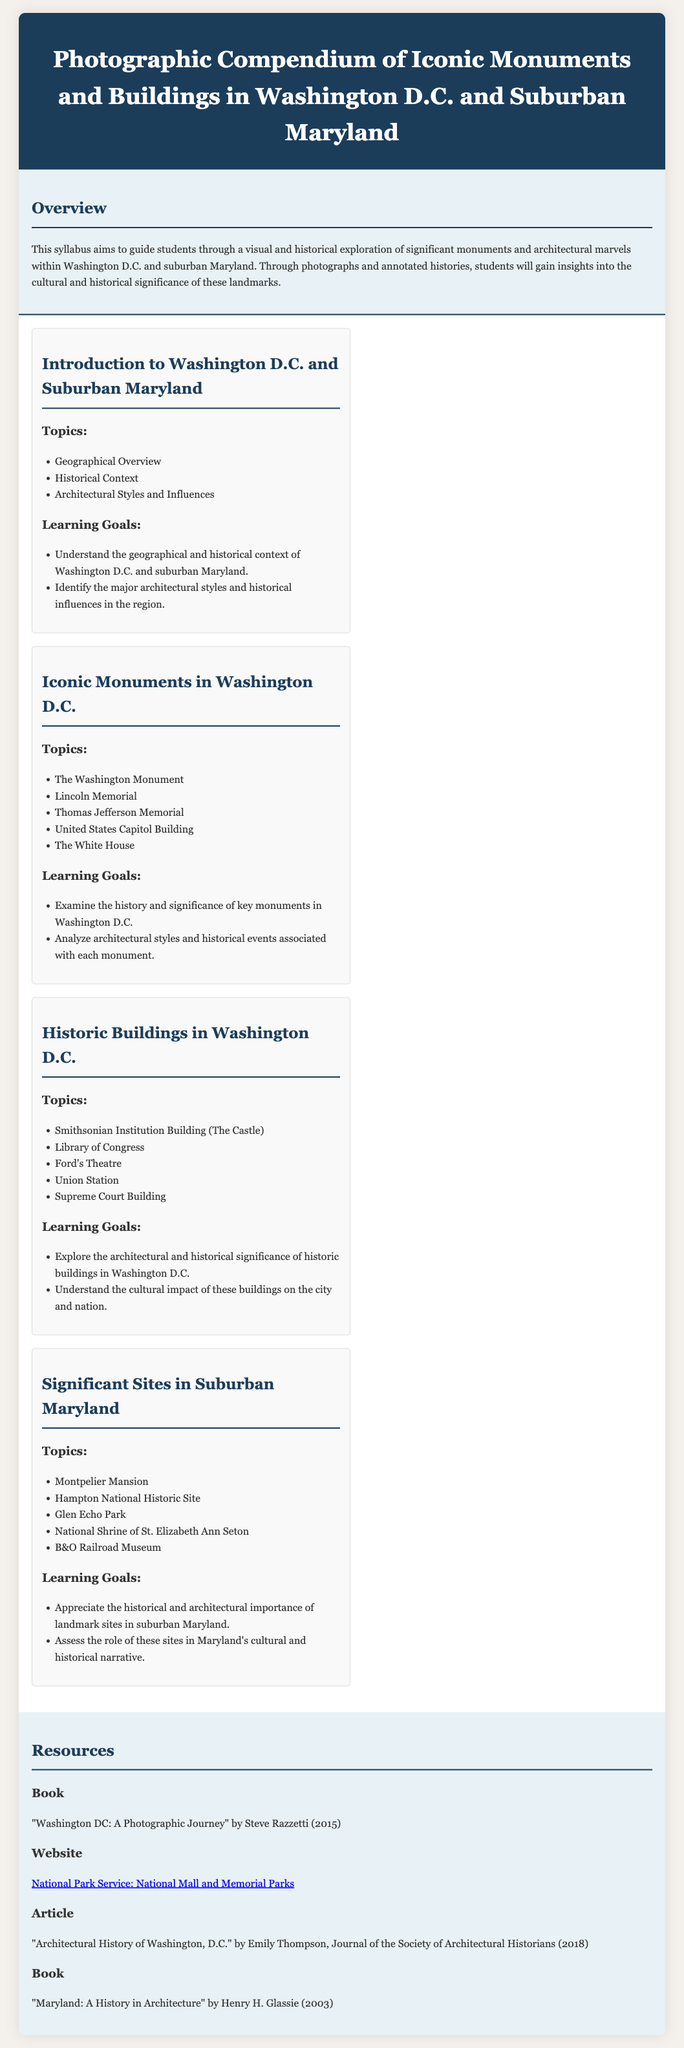What is the title of the syllabus? The title of the syllabus is listed at the top of the document.
Answer: Photographic Compendium of Iconic Monuments and Buildings in Washington D.C. and Suburban Maryland What year was the book "Washington DC: A Photographic Journey" published? The publication year is mentioned in the resources section of the document.
Answer: 2015 How many modules are there in the syllabus? The number of modules can be counted from the modules section of the document.
Answer: 4 Which memorial is associated with Abraham Lincoln? This information is found under the section discussing iconic monuments in Washington D.C.
Answer: Lincoln Memorial What is a significant site listed in Suburban Maryland? This can be retrieved from the topics listed in the Suburban Maryland module.
Answer: Montpelier Mansion What purpose does the syllabus aim to achieve? A brief overview states the goals of the syllabus in the introduction section.
Answer: Guide students through a visual and historical exploration What architectural style is discussed in the introduction module? The introduction module lists key topics of discussion, including architectural styles.
Answer: Architectural Styles and Influences Which resource is related to the architectural history of Washington D.C.? The resource section contains articles and books; this specific article is mentioned.
Answer: "Architectural History of Washington, D.C." What type of site is the B&O Railroad Museum? The context is provided in the module discussing significant sites in Suburban Maryland.
Answer: Significant site 